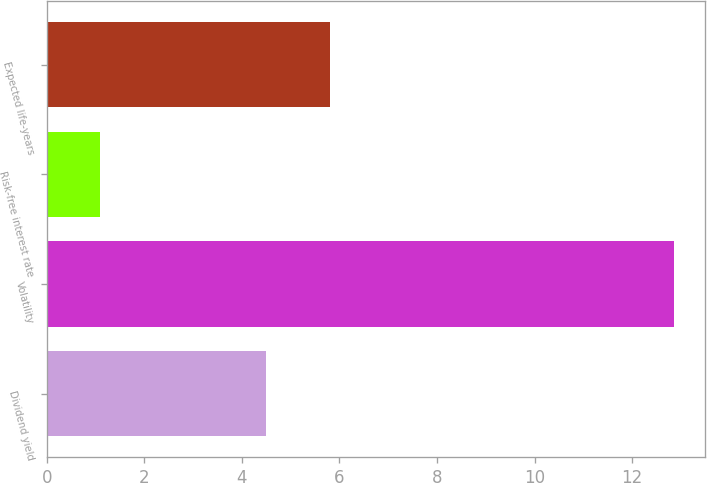Convert chart to OTSL. <chart><loc_0><loc_0><loc_500><loc_500><bar_chart><fcel>Dividend yield<fcel>Volatility<fcel>Risk-free interest rate<fcel>Expected life-years<nl><fcel>4.5<fcel>12.86<fcel>1.08<fcel>5.8<nl></chart> 